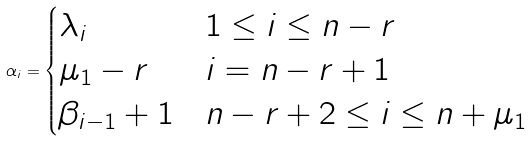<formula> <loc_0><loc_0><loc_500><loc_500>\alpha _ { i } = \begin{cases} \lambda _ { i } & 1 \leq i \leq n - r \\ \mu _ { 1 } - r & i = n - r + 1 \\ \beta _ { i - 1 } + 1 & n - r + 2 \leq i \leq n + \mu _ { 1 } \end{cases}</formula> 